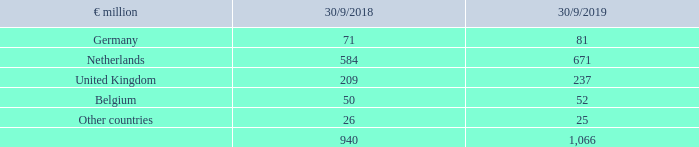The plan assets of METRO are distributed between the following countries:
The above commitments are valued on the basis of actuarial calculations in accordance with relevant provisions of IAS 19. The basis for the measurement is the legal and economic circumstances prevailing in each country.
What is the valuation of the commitments in the table based on? Valued on the basis of actuarial calculations in accordance with relevant provisions of ias 19. What is the basis for the measurements? The legal and economic circumstances prevailing in each country. What are the countries in the table of which the plan assets of METRO are distributed in? Germany, netherlands, united kingdom, belgium, other countries. In which year was the amount for Belgium larger? 52>50
Answer: 2019. What was the change in the amount for Germany in FY2019 from FY2018?
Answer scale should be: million. 81-71
Answer: 10. What was the percentage change in the amount for Germany in FY2019 from FY2018?
Answer scale should be: percent. (81-71)/71
Answer: 14.08. 